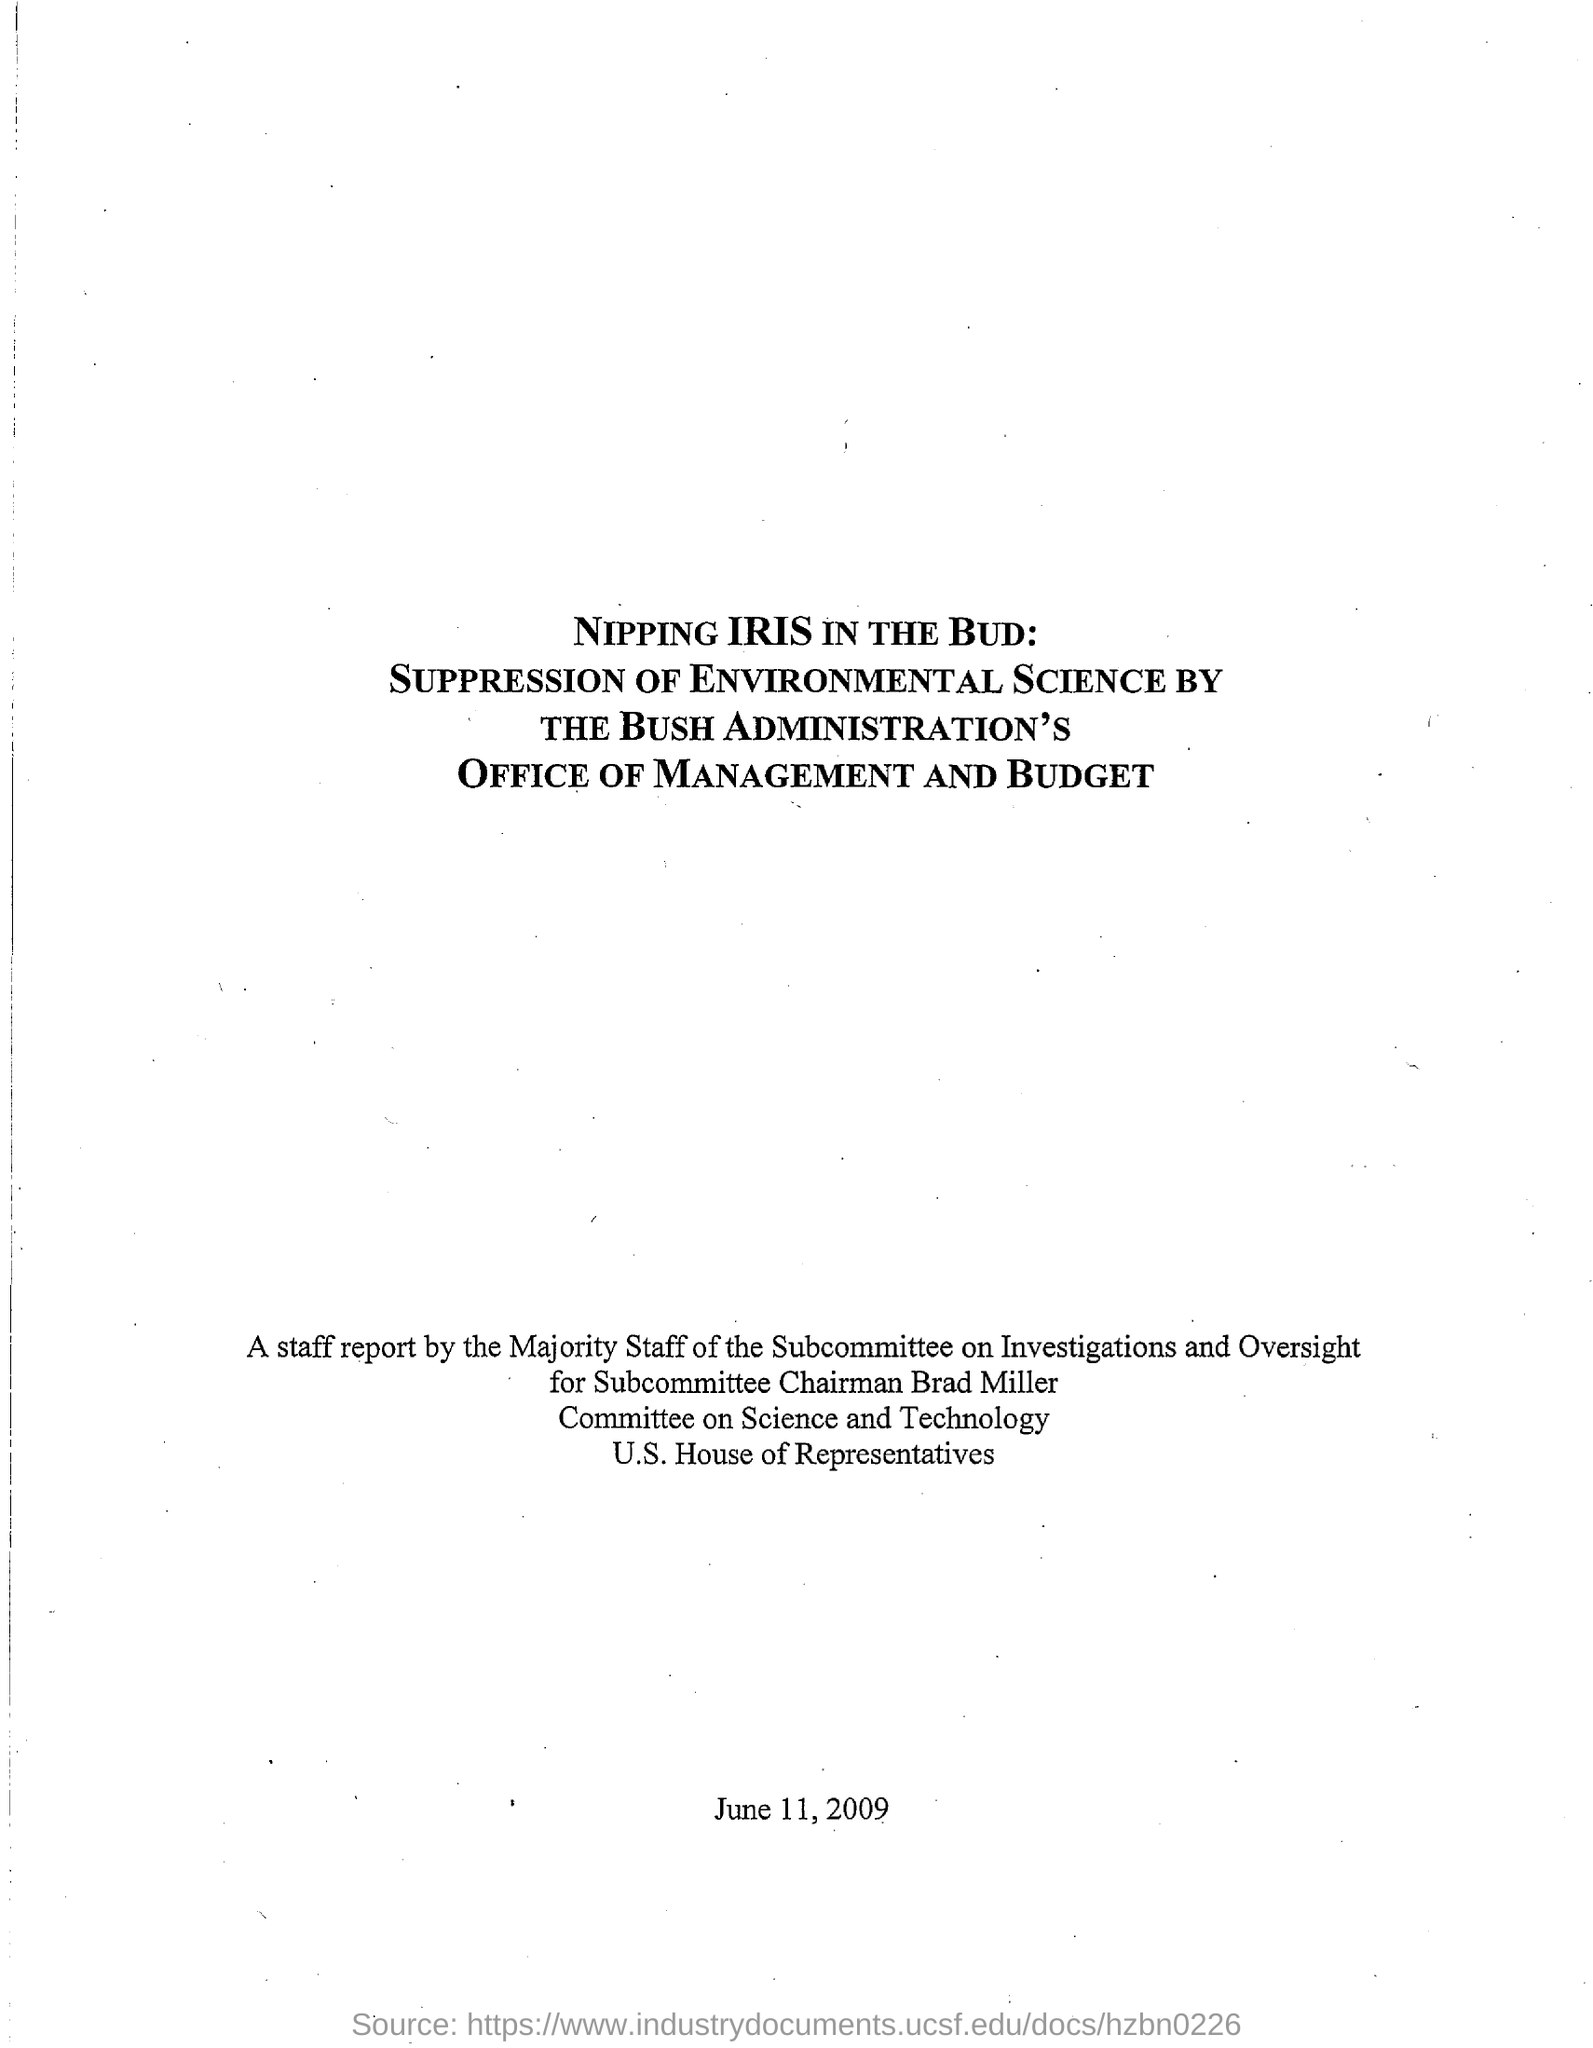What is the date mentioned in the document?
Make the answer very short. June 11, 2009. 